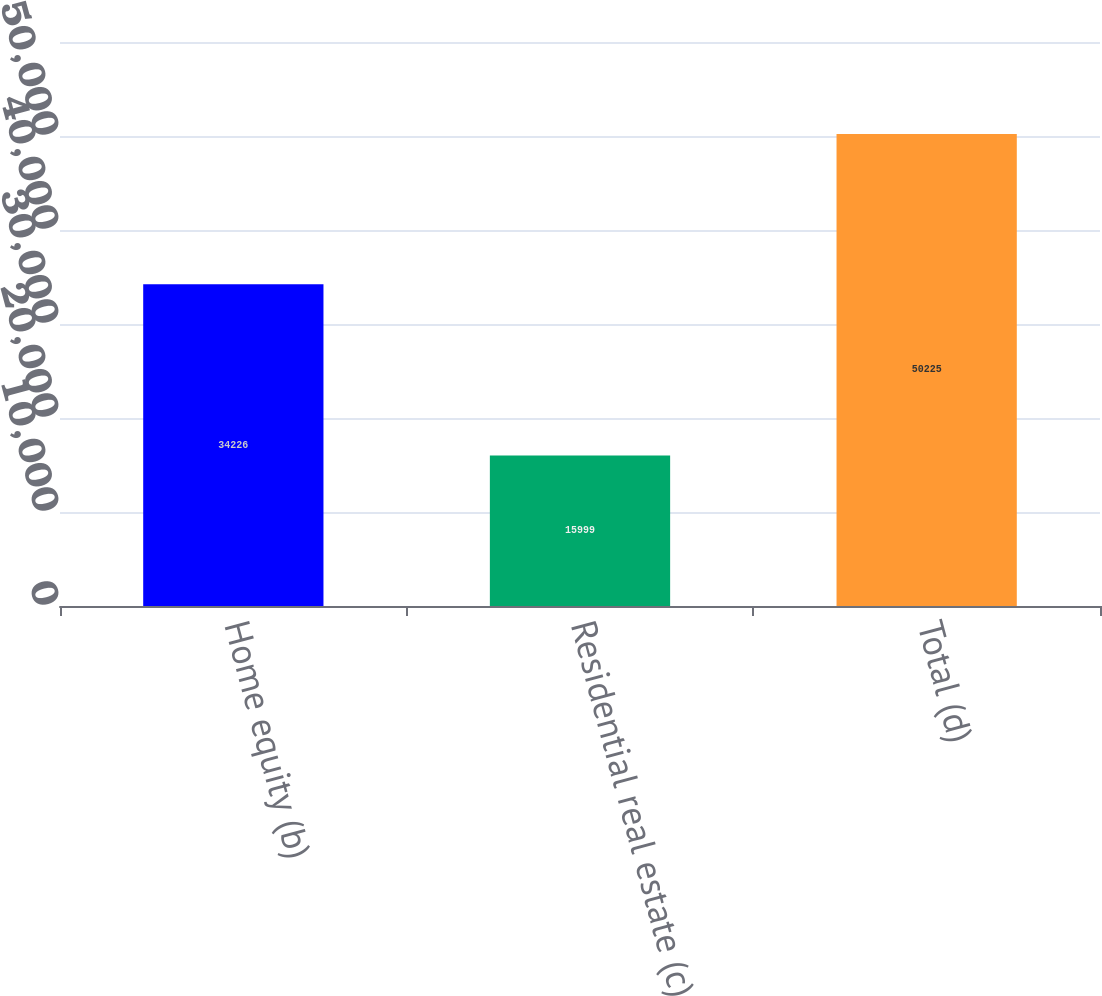Convert chart. <chart><loc_0><loc_0><loc_500><loc_500><bar_chart><fcel>Home equity (b)<fcel>Residential real estate (c)<fcel>Total (d)<nl><fcel>34226<fcel>15999<fcel>50225<nl></chart> 